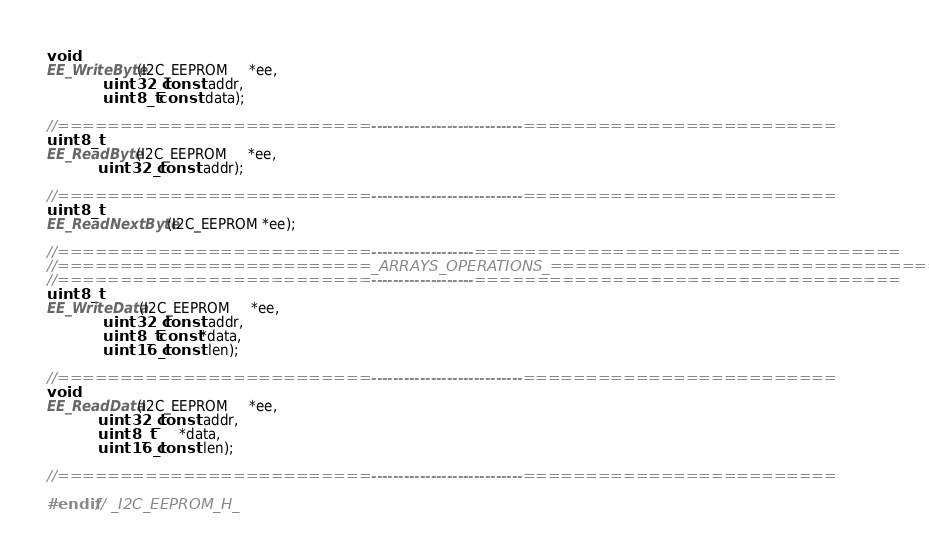Convert code to text. <code><loc_0><loc_0><loc_500><loc_500><_C_>void
EE_WriteByte(I2C_EEPROM     *ee,
			 uint32_t const  addr,
			 uint8_t  const  data);

//=========================----------------------------=========================
uint8_t
EE_ReadByte(I2C_EEPROM     *ee,
			uint32_t const  addr);

//=========================----------------------------=========================
uint8_t
EE_ReadNextByte(I2C_EEPROM *ee);

//=========================-------------------==================================
//=========================_ARRAYS_OPERATIONS_==================================
//=========================-------------------==================================
uint8_t
EE_WriteData(I2C_EEPROM     *ee,
			 uint32_t const  addr,
			 uint8_t  const *data,
			 uint16_t const  len);

//=========================----------------------------=========================
void
EE_ReadData(I2C_EEPROM     *ee,
			uint32_t const  addr,
			uint8_t        *data,
			uint16_t const  len);

//=========================----------------------------=========================

#endif // _I2C_EEPROM_H_
</code> 